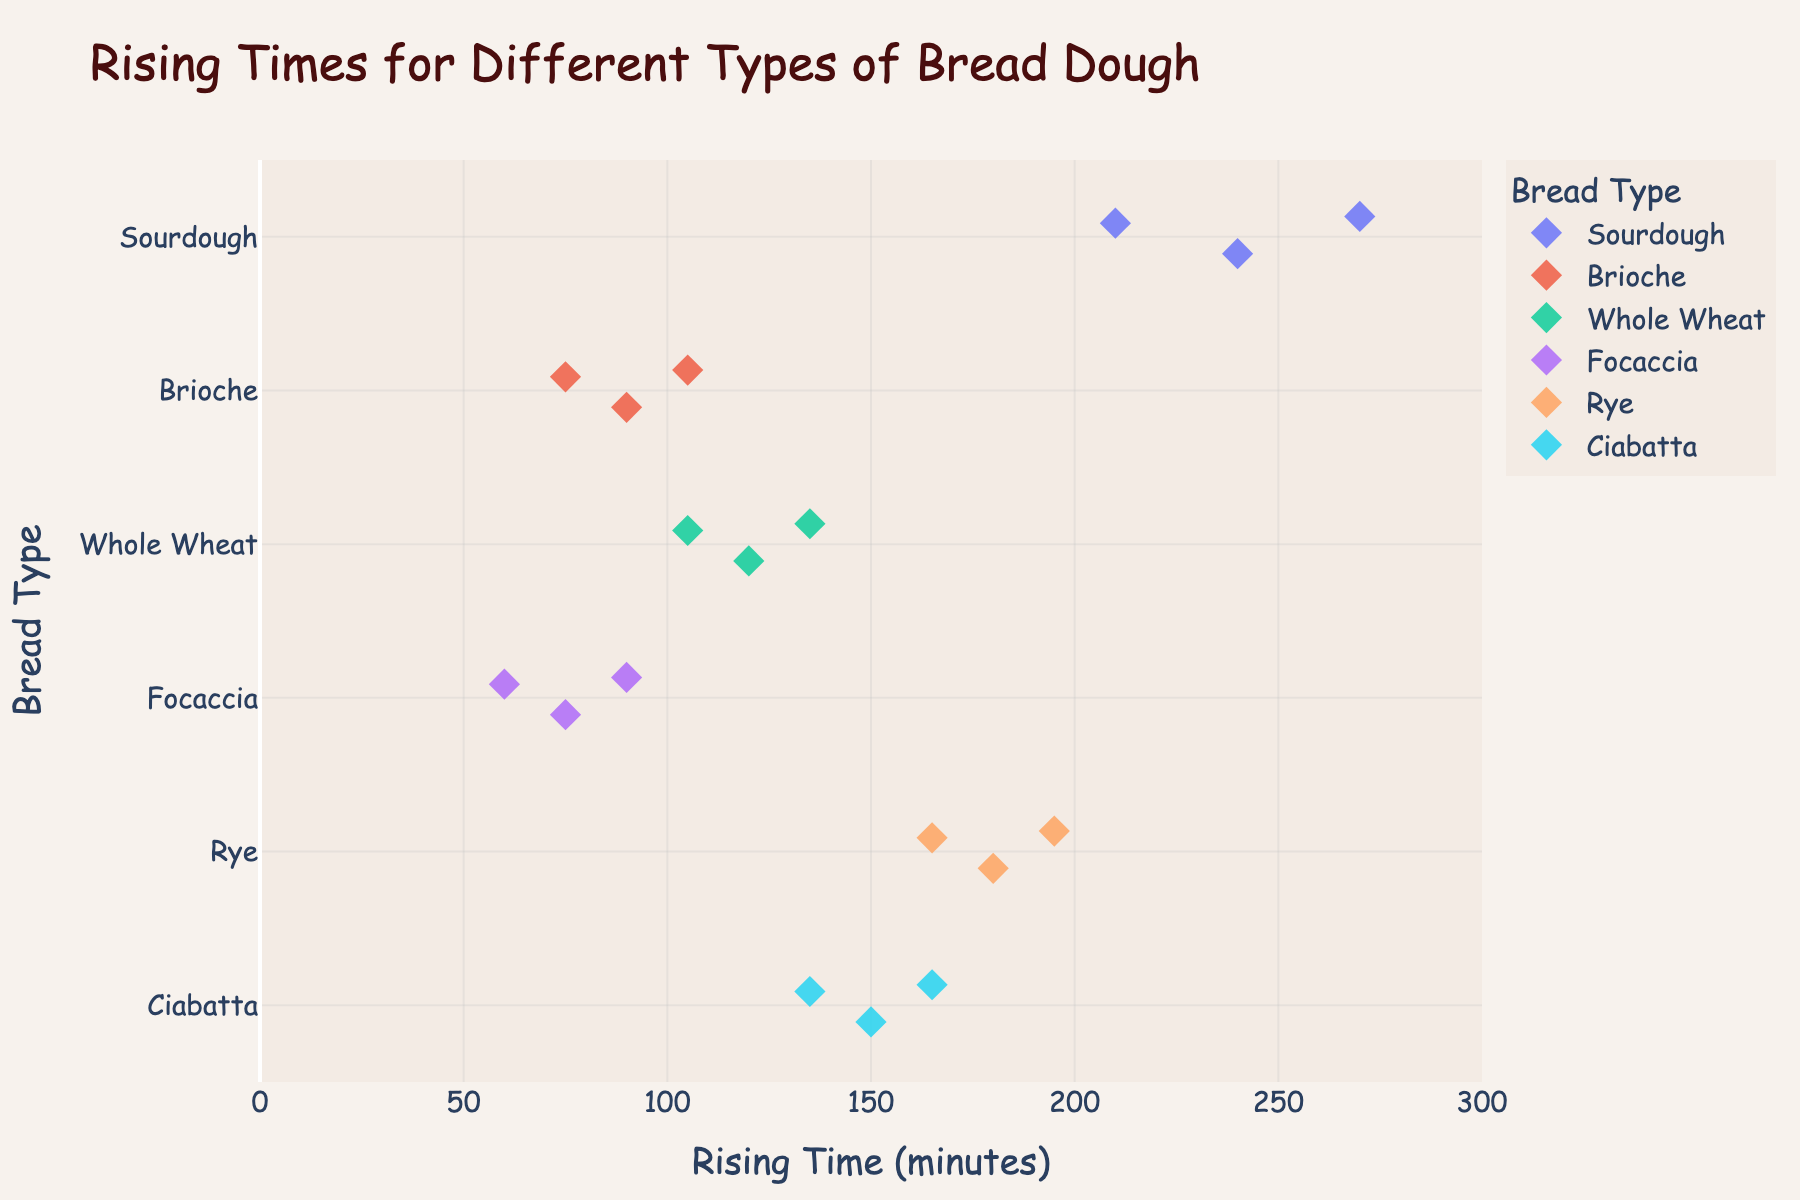What's the title of the plot? The title is located at the top of the plot and is meant to give viewers an overview of the subject matter being presented. In this case, the title is very clear and specifies exactly what the plot is about.
Answer: Rising Times for Different Types of Bread Dough How many different bread types are shown in the plot? The different bread types are listed along the y-axis. In this plot, there are multiple categories representing each type of bread dough. By counting the unique categories, we can determine the number.
Answer: 6 For which bread type do the rising times range the most? We can determine the range by looking at the spread of the points along the x-axis for each type of bread. The bread type with the widest spread is the one with the largest range of rising times.
Answer: Sourdough Which bread type has the shortest rising time? To identify the shortest rising time, we look at the points closest to the origin on the x-axis. The bread type associated with this point will have the shortest rising time.
Answer: Focaccia What's the average rising time for Sourdough? To find the average rising time, sum all the rising times for sourdough and divide by the number of data points for this bread type. Sum = 240 + 210 + 270 = 720; Number of data points = 3; Average = 720 / 3
Answer: 240 Which bread type has the longest median rising time? To find the median rising time for each bread type, list their rising times in order and find the middle value. Compare these median values across bread types to determine the longest.
Answer: Sourdough What is the spread of rising times for Brioche? The spread can be determined by looking at the difference between the maximum and minimum rising times for Brioche. From the plot, identify the points for Brioche and subtract the minimum from the maximum.
Answer: 30 For which bread type are all rising times less than 100 minutes? By checking the upper limit of the x-axis points for each bread type, we can identify if all points are below 100 minutes. The bread type with all points below this threshold is our answer.
Answer: Focaccia Which bread types have rising times between 75 and 120 minutes? Look at the plot and identify all the bread types whose points lie between the 75 and 120-minute marks on the x-axis. Multiple bread types may fall within this range.
Answer: Brioche, Whole Wheat, Focaccia 